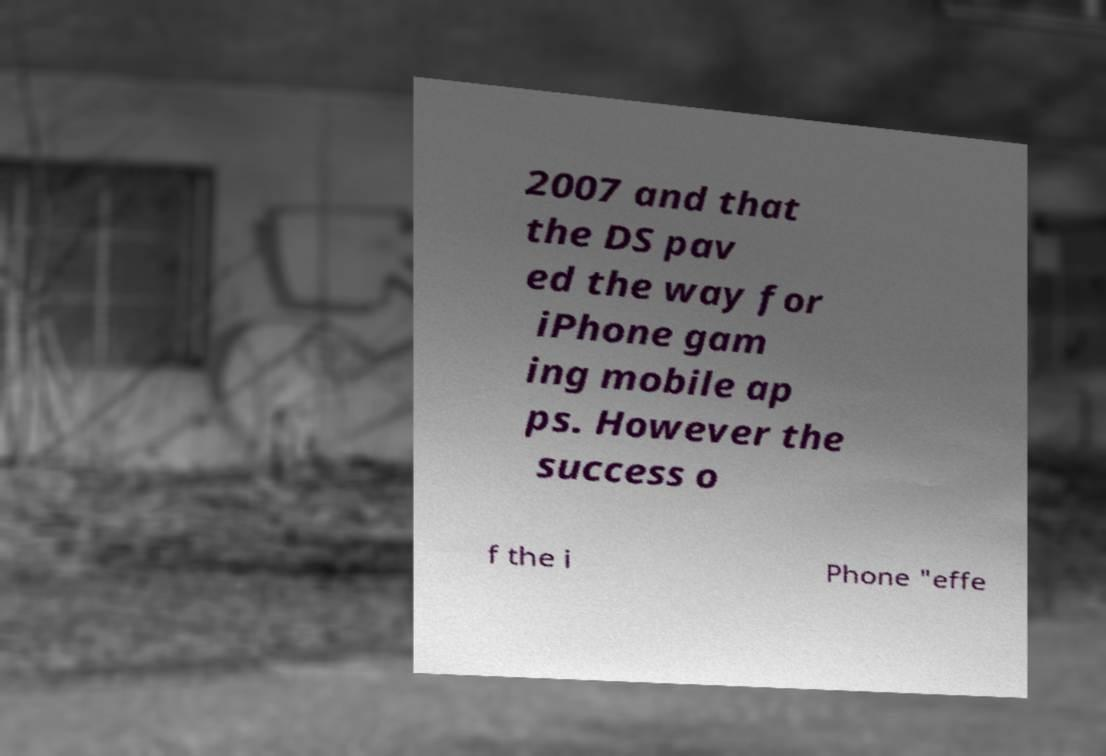Can you accurately transcribe the text from the provided image for me? 2007 and that the DS pav ed the way for iPhone gam ing mobile ap ps. However the success o f the i Phone "effe 